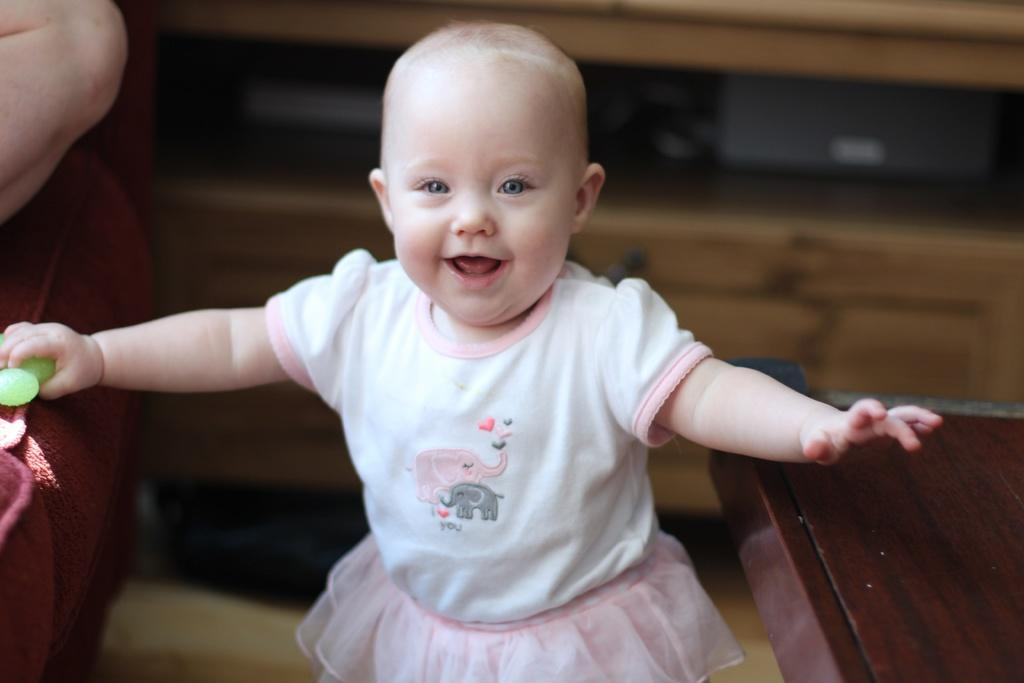What is the main subject of the image? There is a baby in the center of the image. What is the baby holding in the image? The baby is holding an object. Can you describe the background of the image? There is a person's hand, a couch, a table, and a cupboard visible in the background. What type of engine is powering the baby's movements in the image? There is no engine present in the image, and the baby's movements are not powered by an engine. 